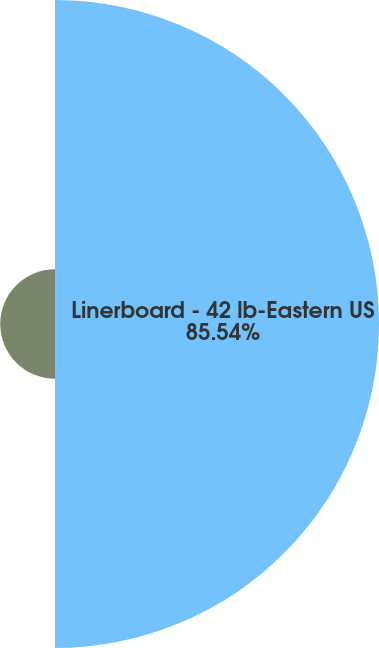<chart> <loc_0><loc_0><loc_500><loc_500><pie_chart><fcel>Linerboard - 42 lb-Eastern US<fcel>Recycling - old corrugated<nl><fcel>85.54%<fcel>14.46%<nl></chart> 